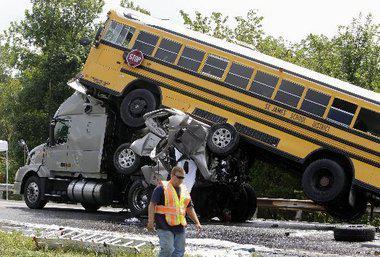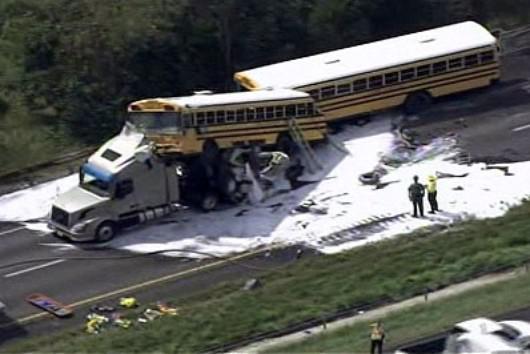The first image is the image on the left, the second image is the image on the right. Considering the images on both sides, is "The right image shows a large tow-truck with a flat-fronted bus tilted behind it and overlapping another bus, on a road with white foam on it." valid? Answer yes or no. Yes. The first image is the image on the left, the second image is the image on the right. Examine the images to the left and right. Is the description "Exactly one bus is on a truck." accurate? Answer yes or no. No. 